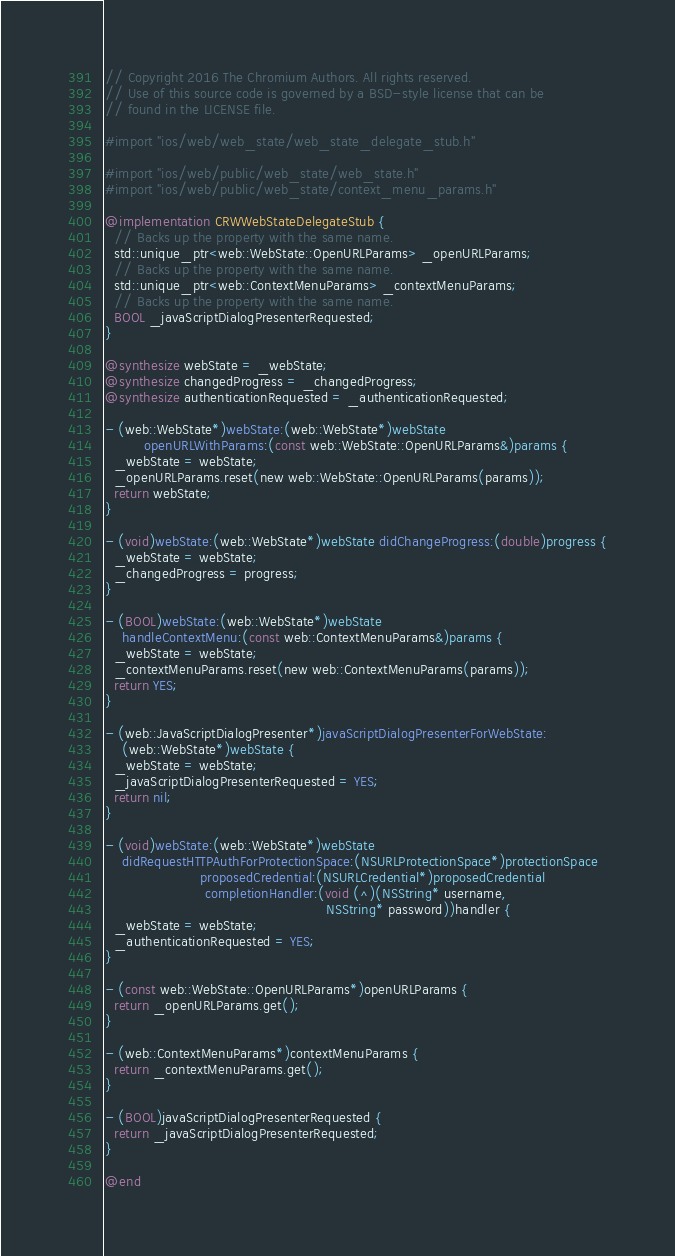<code> <loc_0><loc_0><loc_500><loc_500><_ObjectiveC_>// Copyright 2016 The Chromium Authors. All rights reserved.
// Use of this source code is governed by a BSD-style license that can be
// found in the LICENSE file.

#import "ios/web/web_state/web_state_delegate_stub.h"

#import "ios/web/public/web_state/web_state.h"
#import "ios/web/public/web_state/context_menu_params.h"

@implementation CRWWebStateDelegateStub {
  // Backs up the property with the same name.
  std::unique_ptr<web::WebState::OpenURLParams> _openURLParams;
  // Backs up the property with the same name.
  std::unique_ptr<web::ContextMenuParams> _contextMenuParams;
  // Backs up the property with the same name.
  BOOL _javaScriptDialogPresenterRequested;
}

@synthesize webState = _webState;
@synthesize changedProgress = _changedProgress;
@synthesize authenticationRequested = _authenticationRequested;

- (web::WebState*)webState:(web::WebState*)webState
         openURLWithParams:(const web::WebState::OpenURLParams&)params {
  _webState = webState;
  _openURLParams.reset(new web::WebState::OpenURLParams(params));
  return webState;
}

- (void)webState:(web::WebState*)webState didChangeProgress:(double)progress {
  _webState = webState;
  _changedProgress = progress;
}

- (BOOL)webState:(web::WebState*)webState
    handleContextMenu:(const web::ContextMenuParams&)params {
  _webState = webState;
  _contextMenuParams.reset(new web::ContextMenuParams(params));
  return YES;
}

- (web::JavaScriptDialogPresenter*)javaScriptDialogPresenterForWebState:
    (web::WebState*)webState {
  _webState = webState;
  _javaScriptDialogPresenterRequested = YES;
  return nil;
}

- (void)webState:(web::WebState*)webState
    didRequestHTTPAuthForProtectionSpace:(NSURLProtectionSpace*)protectionSpace
                      proposedCredential:(NSURLCredential*)proposedCredential
                       completionHandler:(void (^)(NSString* username,
                                                   NSString* password))handler {
  _webState = webState;
  _authenticationRequested = YES;
}

- (const web::WebState::OpenURLParams*)openURLParams {
  return _openURLParams.get();
}

- (web::ContextMenuParams*)contextMenuParams {
  return _contextMenuParams.get();
}

- (BOOL)javaScriptDialogPresenterRequested {
  return _javaScriptDialogPresenterRequested;
}

@end
</code> 